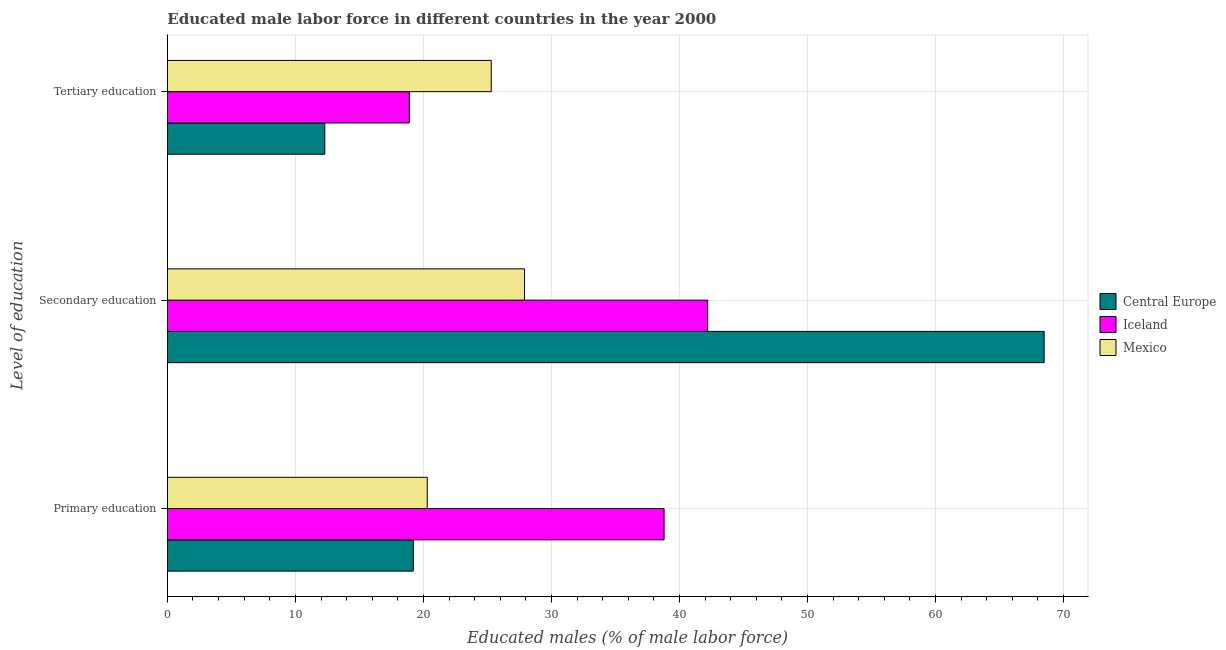How many groups of bars are there?
Your answer should be compact. 3. Are the number of bars on each tick of the Y-axis equal?
Make the answer very short. Yes. How many bars are there on the 1st tick from the bottom?
Offer a terse response. 3. What is the label of the 2nd group of bars from the top?
Offer a very short reply. Secondary education. What is the percentage of male labor force who received secondary education in Iceland?
Make the answer very short. 42.2. Across all countries, what is the maximum percentage of male labor force who received tertiary education?
Provide a short and direct response. 25.3. Across all countries, what is the minimum percentage of male labor force who received secondary education?
Make the answer very short. 27.9. In which country was the percentage of male labor force who received primary education maximum?
Ensure brevity in your answer.  Iceland. In which country was the percentage of male labor force who received tertiary education minimum?
Your answer should be compact. Central Europe. What is the total percentage of male labor force who received tertiary education in the graph?
Give a very brief answer. 56.5. What is the difference between the percentage of male labor force who received tertiary education in Central Europe and that in Iceland?
Your response must be concise. -6.6. What is the difference between the percentage of male labor force who received primary education in Mexico and the percentage of male labor force who received tertiary education in Central Europe?
Your answer should be compact. 8. What is the average percentage of male labor force who received secondary education per country?
Your answer should be compact. 46.2. What is the difference between the percentage of male labor force who received primary education and percentage of male labor force who received secondary education in Central Europe?
Provide a succinct answer. -49.28. In how many countries, is the percentage of male labor force who received primary education greater than 8 %?
Your response must be concise. 3. What is the ratio of the percentage of male labor force who received secondary education in Mexico to that in Central Europe?
Your answer should be very brief. 0.41. What is the difference between the highest and the second highest percentage of male labor force who received secondary education?
Offer a very short reply. 26.29. What is the difference between the highest and the lowest percentage of male labor force who received secondary education?
Give a very brief answer. 40.59. In how many countries, is the percentage of male labor force who received primary education greater than the average percentage of male labor force who received primary education taken over all countries?
Ensure brevity in your answer.  1. What does the 3rd bar from the top in Secondary education represents?
Your answer should be compact. Central Europe. What does the 2nd bar from the bottom in Primary education represents?
Ensure brevity in your answer.  Iceland. How many countries are there in the graph?
Provide a short and direct response. 3. Where does the legend appear in the graph?
Offer a terse response. Center right. How many legend labels are there?
Provide a succinct answer. 3. What is the title of the graph?
Ensure brevity in your answer.  Educated male labor force in different countries in the year 2000. What is the label or title of the X-axis?
Your response must be concise. Educated males (% of male labor force). What is the label or title of the Y-axis?
Keep it short and to the point. Level of education. What is the Educated males (% of male labor force) in Central Europe in Primary education?
Your answer should be very brief. 19.21. What is the Educated males (% of male labor force) of Iceland in Primary education?
Your response must be concise. 38.8. What is the Educated males (% of male labor force) in Mexico in Primary education?
Offer a terse response. 20.3. What is the Educated males (% of male labor force) in Central Europe in Secondary education?
Provide a succinct answer. 68.49. What is the Educated males (% of male labor force) in Iceland in Secondary education?
Provide a succinct answer. 42.2. What is the Educated males (% of male labor force) in Mexico in Secondary education?
Make the answer very short. 27.9. What is the Educated males (% of male labor force) of Central Europe in Tertiary education?
Provide a succinct answer. 12.3. What is the Educated males (% of male labor force) of Iceland in Tertiary education?
Offer a terse response. 18.9. What is the Educated males (% of male labor force) in Mexico in Tertiary education?
Make the answer very short. 25.3. Across all Level of education, what is the maximum Educated males (% of male labor force) of Central Europe?
Ensure brevity in your answer.  68.49. Across all Level of education, what is the maximum Educated males (% of male labor force) of Iceland?
Keep it short and to the point. 42.2. Across all Level of education, what is the maximum Educated males (% of male labor force) of Mexico?
Keep it short and to the point. 27.9. Across all Level of education, what is the minimum Educated males (% of male labor force) of Central Europe?
Provide a short and direct response. 12.3. Across all Level of education, what is the minimum Educated males (% of male labor force) in Iceland?
Provide a succinct answer. 18.9. Across all Level of education, what is the minimum Educated males (% of male labor force) of Mexico?
Your answer should be compact. 20.3. What is the total Educated males (% of male labor force) of Central Europe in the graph?
Ensure brevity in your answer.  100. What is the total Educated males (% of male labor force) of Iceland in the graph?
Ensure brevity in your answer.  99.9. What is the total Educated males (% of male labor force) of Mexico in the graph?
Your response must be concise. 73.5. What is the difference between the Educated males (% of male labor force) in Central Europe in Primary education and that in Secondary education?
Provide a succinct answer. -49.28. What is the difference between the Educated males (% of male labor force) in Iceland in Primary education and that in Secondary education?
Give a very brief answer. -3.4. What is the difference between the Educated males (% of male labor force) of Central Europe in Primary education and that in Tertiary education?
Make the answer very short. 6.92. What is the difference between the Educated males (% of male labor force) in Iceland in Primary education and that in Tertiary education?
Your response must be concise. 19.9. What is the difference between the Educated males (% of male labor force) in Mexico in Primary education and that in Tertiary education?
Your answer should be compact. -5. What is the difference between the Educated males (% of male labor force) in Central Europe in Secondary education and that in Tertiary education?
Offer a very short reply. 56.19. What is the difference between the Educated males (% of male labor force) of Iceland in Secondary education and that in Tertiary education?
Your answer should be very brief. 23.3. What is the difference between the Educated males (% of male labor force) in Central Europe in Primary education and the Educated males (% of male labor force) in Iceland in Secondary education?
Your response must be concise. -22.99. What is the difference between the Educated males (% of male labor force) in Central Europe in Primary education and the Educated males (% of male labor force) in Mexico in Secondary education?
Offer a terse response. -8.69. What is the difference between the Educated males (% of male labor force) of Iceland in Primary education and the Educated males (% of male labor force) of Mexico in Secondary education?
Provide a succinct answer. 10.9. What is the difference between the Educated males (% of male labor force) of Central Europe in Primary education and the Educated males (% of male labor force) of Iceland in Tertiary education?
Ensure brevity in your answer.  0.31. What is the difference between the Educated males (% of male labor force) of Central Europe in Primary education and the Educated males (% of male labor force) of Mexico in Tertiary education?
Ensure brevity in your answer.  -6.09. What is the difference between the Educated males (% of male labor force) in Iceland in Primary education and the Educated males (% of male labor force) in Mexico in Tertiary education?
Provide a short and direct response. 13.5. What is the difference between the Educated males (% of male labor force) in Central Europe in Secondary education and the Educated males (% of male labor force) in Iceland in Tertiary education?
Offer a very short reply. 49.59. What is the difference between the Educated males (% of male labor force) of Central Europe in Secondary education and the Educated males (% of male labor force) of Mexico in Tertiary education?
Make the answer very short. 43.19. What is the average Educated males (% of male labor force) of Central Europe per Level of education?
Offer a very short reply. 33.33. What is the average Educated males (% of male labor force) in Iceland per Level of education?
Keep it short and to the point. 33.3. What is the difference between the Educated males (% of male labor force) of Central Europe and Educated males (% of male labor force) of Iceland in Primary education?
Your answer should be very brief. -19.59. What is the difference between the Educated males (% of male labor force) in Central Europe and Educated males (% of male labor force) in Mexico in Primary education?
Give a very brief answer. -1.09. What is the difference between the Educated males (% of male labor force) in Iceland and Educated males (% of male labor force) in Mexico in Primary education?
Your response must be concise. 18.5. What is the difference between the Educated males (% of male labor force) in Central Europe and Educated males (% of male labor force) in Iceland in Secondary education?
Ensure brevity in your answer.  26.29. What is the difference between the Educated males (% of male labor force) in Central Europe and Educated males (% of male labor force) in Mexico in Secondary education?
Your answer should be very brief. 40.59. What is the difference between the Educated males (% of male labor force) in Central Europe and Educated males (% of male labor force) in Iceland in Tertiary education?
Provide a succinct answer. -6.6. What is the difference between the Educated males (% of male labor force) in Central Europe and Educated males (% of male labor force) in Mexico in Tertiary education?
Provide a succinct answer. -13. What is the difference between the Educated males (% of male labor force) of Iceland and Educated males (% of male labor force) of Mexico in Tertiary education?
Keep it short and to the point. -6.4. What is the ratio of the Educated males (% of male labor force) of Central Europe in Primary education to that in Secondary education?
Ensure brevity in your answer.  0.28. What is the ratio of the Educated males (% of male labor force) of Iceland in Primary education to that in Secondary education?
Your answer should be very brief. 0.92. What is the ratio of the Educated males (% of male labor force) of Mexico in Primary education to that in Secondary education?
Give a very brief answer. 0.73. What is the ratio of the Educated males (% of male labor force) in Central Europe in Primary education to that in Tertiary education?
Offer a very short reply. 1.56. What is the ratio of the Educated males (% of male labor force) in Iceland in Primary education to that in Tertiary education?
Make the answer very short. 2.05. What is the ratio of the Educated males (% of male labor force) in Mexico in Primary education to that in Tertiary education?
Provide a succinct answer. 0.8. What is the ratio of the Educated males (% of male labor force) of Central Europe in Secondary education to that in Tertiary education?
Your response must be concise. 5.57. What is the ratio of the Educated males (% of male labor force) in Iceland in Secondary education to that in Tertiary education?
Provide a succinct answer. 2.23. What is the ratio of the Educated males (% of male labor force) of Mexico in Secondary education to that in Tertiary education?
Your response must be concise. 1.1. What is the difference between the highest and the second highest Educated males (% of male labor force) in Central Europe?
Provide a short and direct response. 49.28. What is the difference between the highest and the lowest Educated males (% of male labor force) in Central Europe?
Give a very brief answer. 56.19. What is the difference between the highest and the lowest Educated males (% of male labor force) in Iceland?
Ensure brevity in your answer.  23.3. What is the difference between the highest and the lowest Educated males (% of male labor force) of Mexico?
Keep it short and to the point. 7.6. 